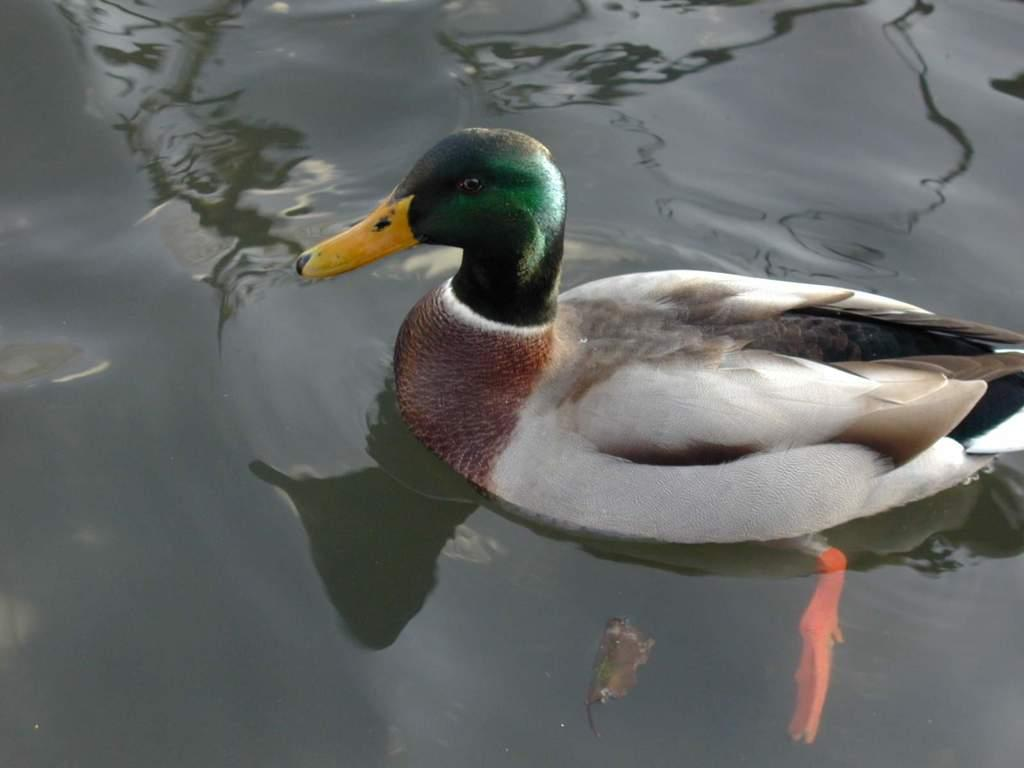What animal is present in the image? There is a duck in the image. What colors can be seen on the duck? The duck is white, black, brown, and green in color. Where is the duck located in the image? The duck is in the water. What type of milk is being served in the image? There is no milk present in the image; it features a duck in the water. What ingredients are used to make the stew in the image? There is no stew present in the image; it features a duck in the water. 